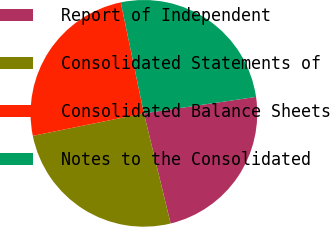Convert chart to OTSL. <chart><loc_0><loc_0><loc_500><loc_500><pie_chart><fcel>Report of Independent<fcel>Consolidated Statements of<fcel>Consolidated Balance Sheets<fcel>Notes to the Consolidated<nl><fcel>23.53%<fcel>25.61%<fcel>24.91%<fcel>25.95%<nl></chart> 